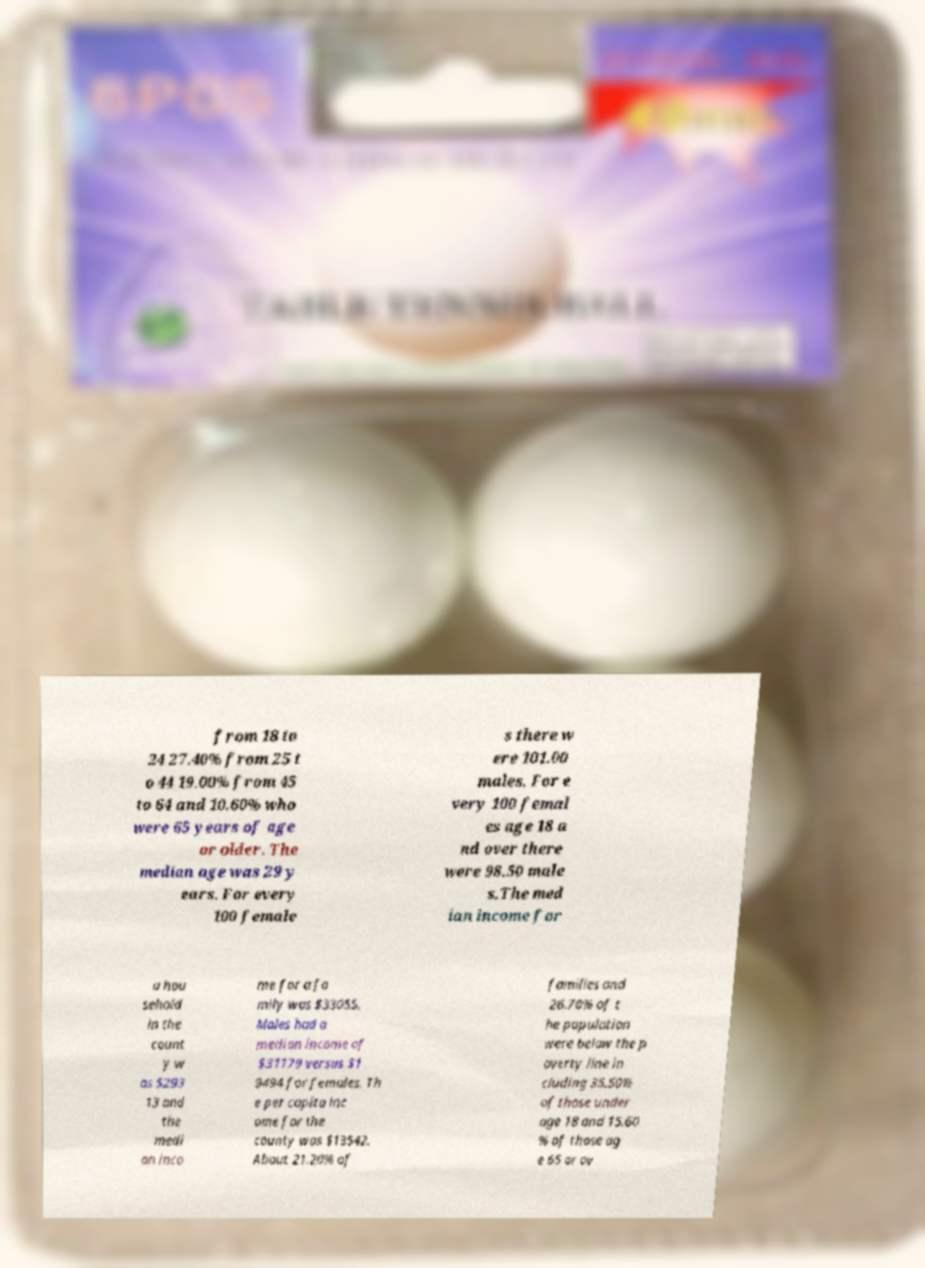Can you accurately transcribe the text from the provided image for me? from 18 to 24 27.40% from 25 t o 44 19.00% from 45 to 64 and 10.60% who were 65 years of age or older. The median age was 29 y ears. For every 100 female s there w ere 101.00 males. For e very 100 femal es age 18 a nd over there were 98.50 male s.The med ian income for a hou sehold in the count y w as $293 13 and the medi an inco me for a fa mily was $33055. Males had a median income of $31179 versus $1 9494 for females. Th e per capita inc ome for the county was $13542. About 21.20% of families and 26.70% of t he population were below the p overty line in cluding 35.50% of those under age 18 and 15.60 % of those ag e 65 or ov 